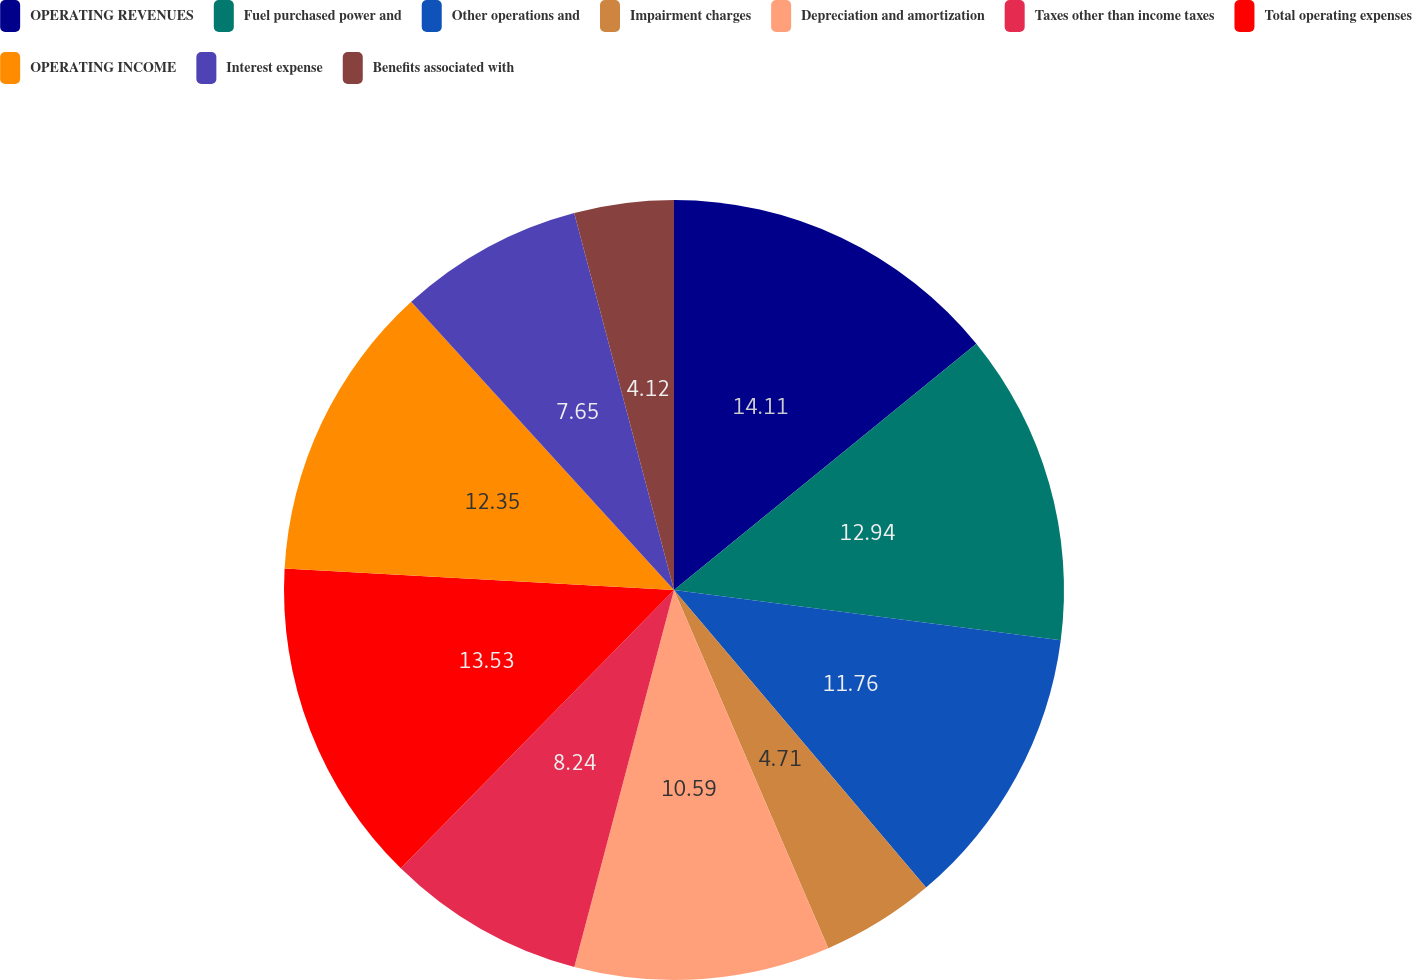Convert chart to OTSL. <chart><loc_0><loc_0><loc_500><loc_500><pie_chart><fcel>OPERATING REVENUES<fcel>Fuel purchased power and<fcel>Other operations and<fcel>Impairment charges<fcel>Depreciation and amortization<fcel>Taxes other than income taxes<fcel>Total operating expenses<fcel>OPERATING INCOME<fcel>Interest expense<fcel>Benefits associated with<nl><fcel>14.12%<fcel>12.94%<fcel>11.76%<fcel>4.71%<fcel>10.59%<fcel>8.24%<fcel>13.53%<fcel>12.35%<fcel>7.65%<fcel>4.12%<nl></chart> 